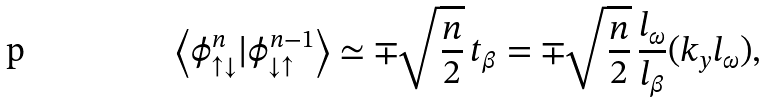<formula> <loc_0><loc_0><loc_500><loc_500>\left < \phi _ { \uparrow \downarrow } ^ { n } | \phi _ { \downarrow \uparrow } ^ { n - 1 } \right > \simeq \mp \sqrt { \frac { n } { 2 } } \, t _ { \beta } = \mp \sqrt { \frac { n } { 2 } } \, \frac { l _ { \omega } } { l _ { \beta } } ( k _ { y } l _ { \omega } ) ,</formula> 